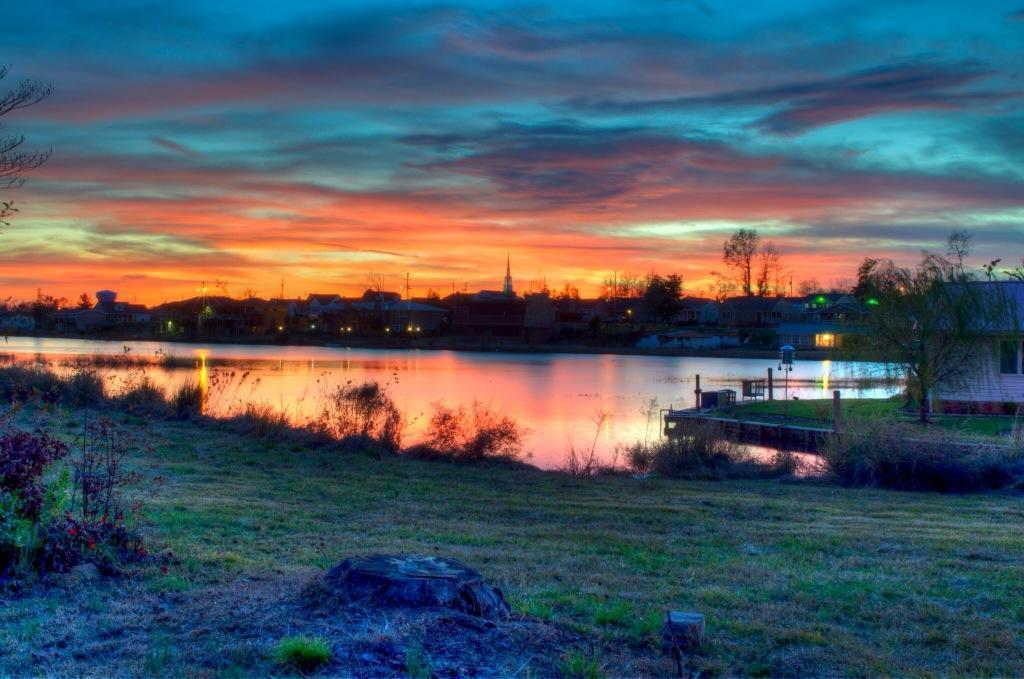What type of natural feature can be seen in the image? There is a lake in the image. What man-made structures are present in the image? There are buildings in the image. What type of vegetation is visible in the image? There are trees, plants, and grass in the image. What are the poles used for in the image? The purpose of the poles is not specified in the image, but they could be used for various purposes such as lighting or signage. What is visible in the background of the image? The sky is visible in the background of the image. What is the skin condition of the trees in the image? There is no mention of a skin condition in the image, as it features a lake, buildings, trees, plants, grass, poles, and the sky. What grade does the lake receive for its water quality in the image? There is no information about the water quality or any grading system in the image. 